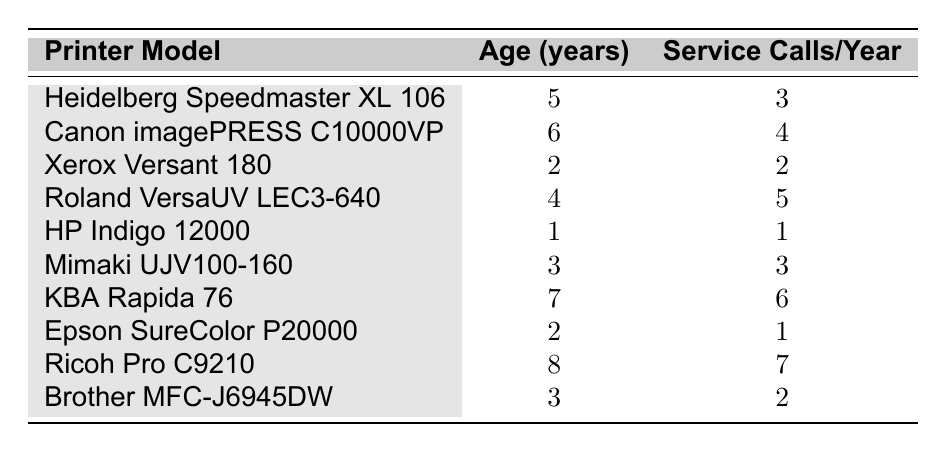What is the age of the Ricoh Pro C9210 printer? The table lists the Ricoh Pro C9210 and shows that its age in years is 8.
Answer: 8 How many service calls does the HP Indigo 12000 make per year? The table indicates that the HP Indigo 12000 printer has 1 service call per year.
Answer: 1 Which printer model has the highest frequency of service calls? By examining the service calls per year, the Ricoh Pro C9210 has the highest at 7 calls per year.
Answer: Ricoh Pro C9210 Is the Canon imagePRESS C10000VP older than the Roland VersaUV LEC3-640? The table shows the Canon imagePRESS C10000VP is 6 years old and the Roland VersaUV LEC3-640 is 4 years old, thus it is older.
Answer: Yes What is the average number of service calls per year for printers older than 5 years? The printers older than 5 years are the Canon imagePRESS C10000VP (4), KBA Rapida 76 (6), and Ricoh Pro C9210 (7). Summing these gives 4 + 6 + 7 = 17. There are 3 such printers, thus the average is 17/3 = 5.67.
Answer: 5.67 How many printers require fewer than 3 service calls per year? The printers with fewer than 3 service calls per year are the HP Indigo 12000 (1), Epson SureColor P20000 (1), and Xerox Versant 180 (2). In total, there are 3 such printers.
Answer: 3 Is there a printer with the same frequency of service calls as its age? Looking at the table, the Mimaki UJV100-160 has 3 years old and 3 service calls per year, indicating they match.
Answer: Yes What is the difference between the maximum and minimum service calls per year among the printers listed? The maximum number of service calls is 7 (Ricoh Pro C9210) and the minimum is 1 (HP Indigo 12000 and Epson SureColor P20000). Calculating the difference: 7 - 1 = 6.
Answer: 6 Which printer has a service call frequency that is more than double its age? The only printer that meets this condition is the KBA Rapida 76 with 6 service calls at 7 years old, since 6 is more than double 7 (4.5).
Answer: No 